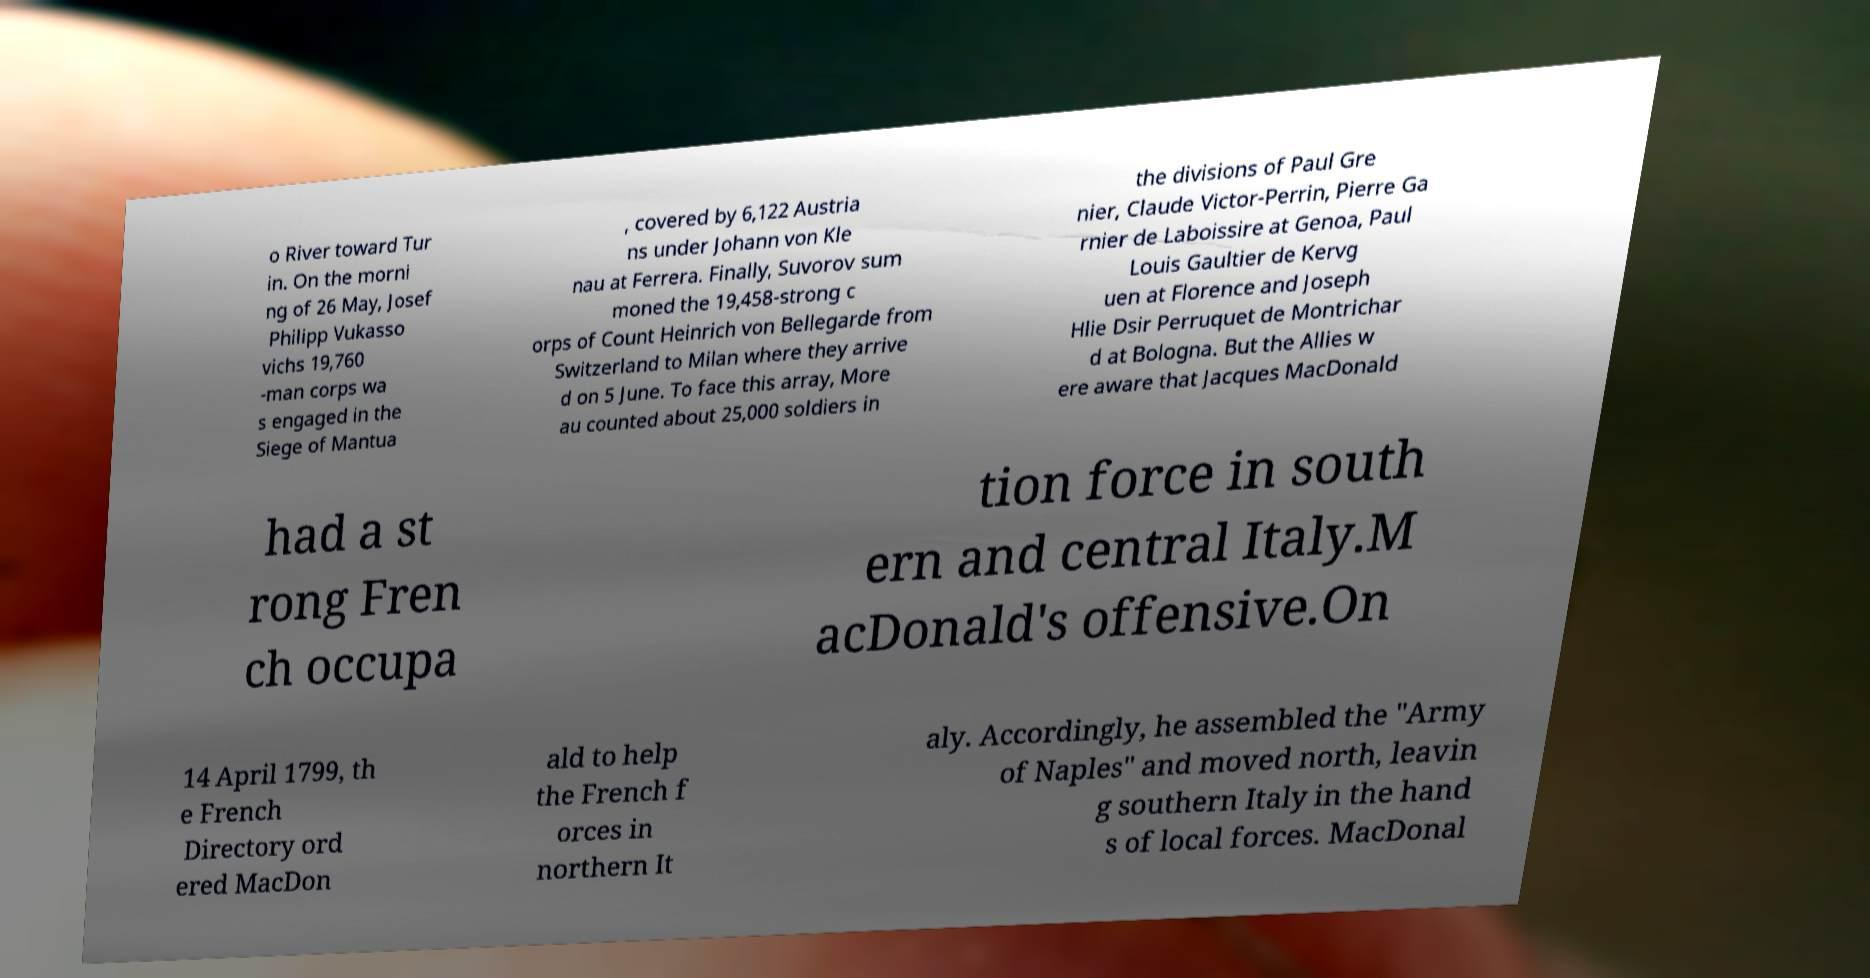Could you extract and type out the text from this image? o River toward Tur in. On the morni ng of 26 May, Josef Philipp Vukasso vichs 19,760 -man corps wa s engaged in the Siege of Mantua , covered by 6,122 Austria ns under Johann von Kle nau at Ferrera. Finally, Suvorov sum moned the 19,458-strong c orps of Count Heinrich von Bellegarde from Switzerland to Milan where they arrive d on 5 June. To face this array, More au counted about 25,000 soldiers in the divisions of Paul Gre nier, Claude Victor-Perrin, Pierre Ga rnier de Laboissire at Genoa, Paul Louis Gaultier de Kervg uen at Florence and Joseph Hlie Dsir Perruquet de Montrichar d at Bologna. But the Allies w ere aware that Jacques MacDonald had a st rong Fren ch occupa tion force in south ern and central Italy.M acDonald's offensive.On 14 April 1799, th e French Directory ord ered MacDon ald to help the French f orces in northern It aly. Accordingly, he assembled the "Army of Naples" and moved north, leavin g southern Italy in the hand s of local forces. MacDonal 